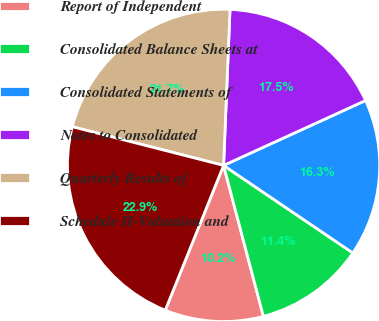Convert chart to OTSL. <chart><loc_0><loc_0><loc_500><loc_500><pie_chart><fcel>Report of Independent<fcel>Consolidated Balance Sheets at<fcel>Consolidated Statements of<fcel>Notes to Consolidated<fcel>Quarterly Results of<fcel>Schedule II-Valuation and<nl><fcel>10.2%<fcel>11.42%<fcel>16.3%<fcel>17.52%<fcel>21.67%<fcel>22.89%<nl></chart> 